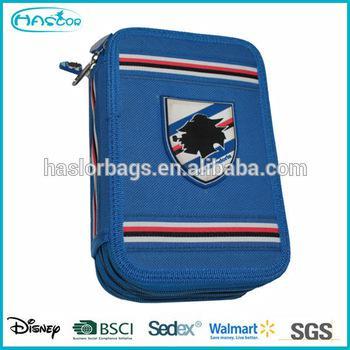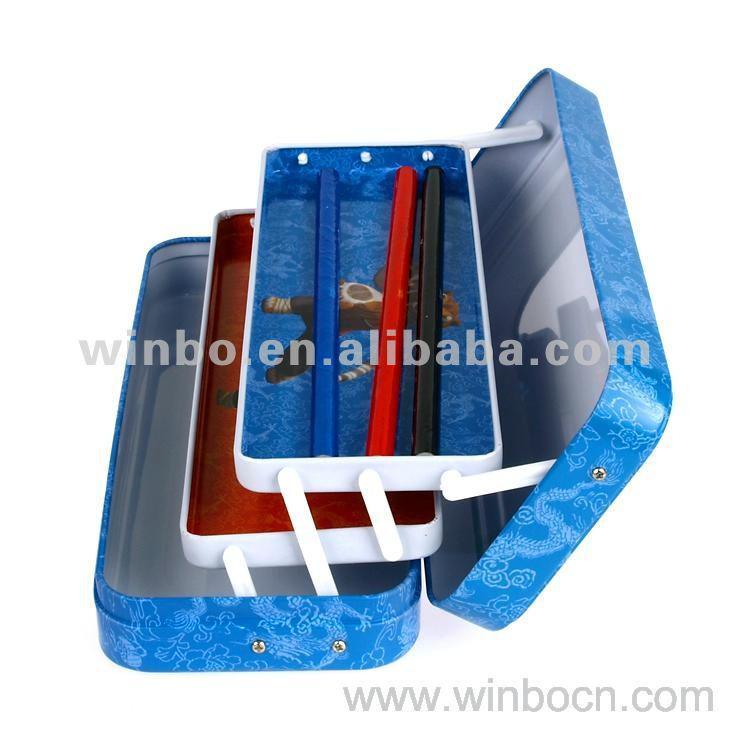The first image is the image on the left, the second image is the image on the right. For the images displayed, is the sentence "There is at least one pen inside an open 3 layered pencil case." factually correct? Answer yes or no. Yes. The first image is the image on the left, the second image is the image on the right. Considering the images on both sides, is "An image shows three variations of the same kind of case, each a different color." valid? Answer yes or no. No. 